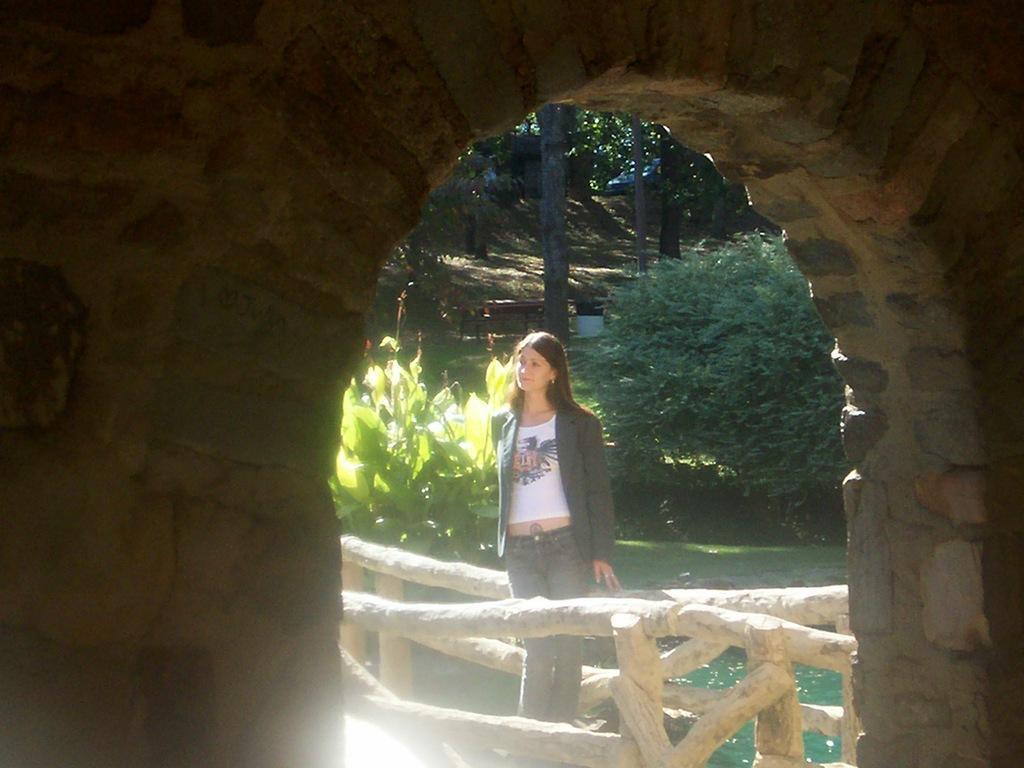Could you give a brief overview of what you see in this image? In the picture I can see the stone wall, here we can see a woman wearing jacket, white T-shirt is standing on the bridge, we can see the water, plants, wooden bench, flower pot, a car on the road and trees in the background. 